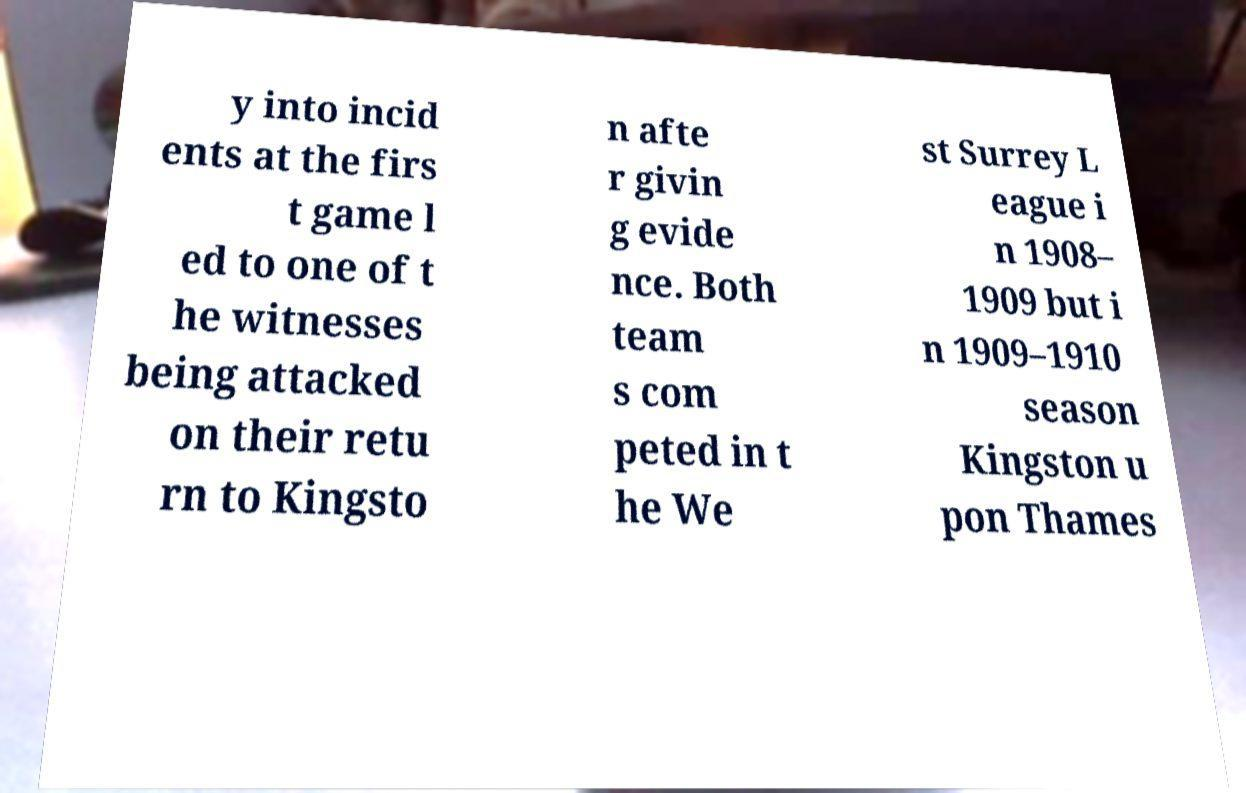For documentation purposes, I need the text within this image transcribed. Could you provide that? y into incid ents at the firs t game l ed to one of t he witnesses being attacked on their retu rn to Kingsto n afte r givin g evide nce. Both team s com peted in t he We st Surrey L eague i n 1908– 1909 but i n 1909–1910 season Kingston u pon Thames 